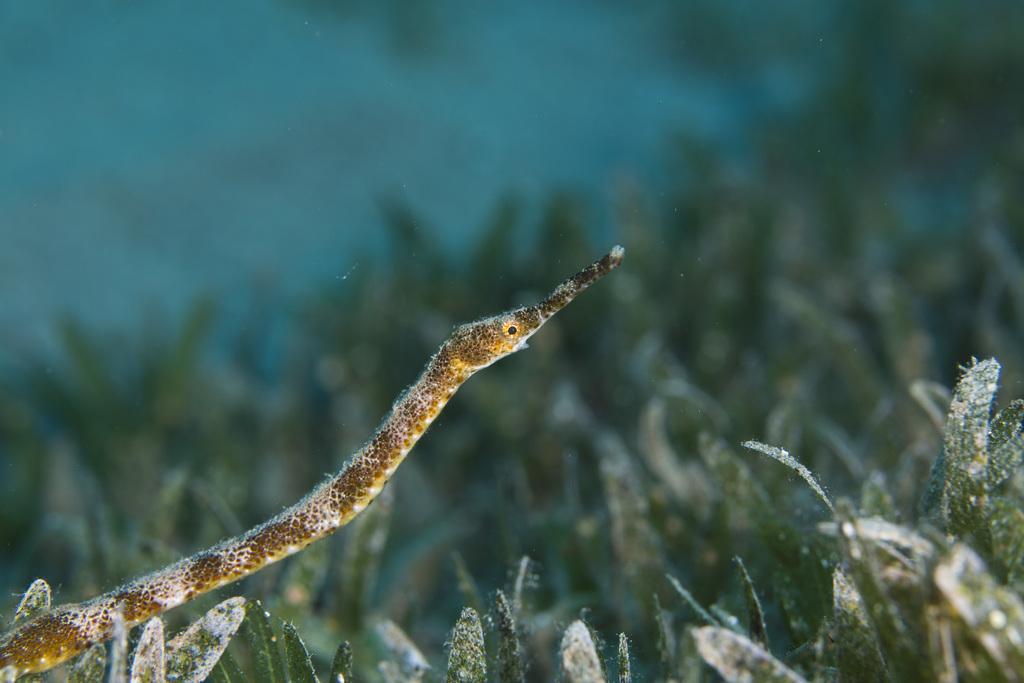In one or two sentences, can you explain what this image depicts? In this image we can see the aquatic animal on the plant and there is the blur background. 